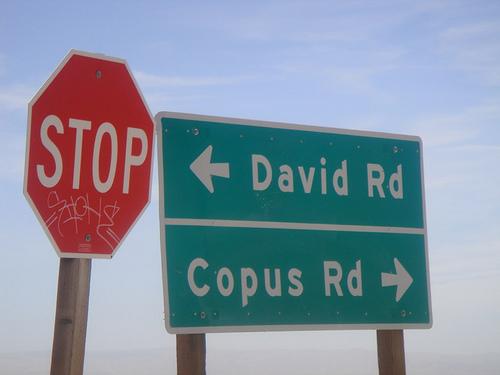Which way is David Rd?
Be succinct. Left. How many signs are there?
Keep it brief. 2. What color is the graffiti lettering?
Write a very short answer. White. 